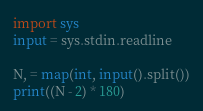Convert code to text. <code><loc_0><loc_0><loc_500><loc_500><_Python_>import sys
input = sys.stdin.readline

N, = map(int, input().split())
print((N - 2) * 180)</code> 